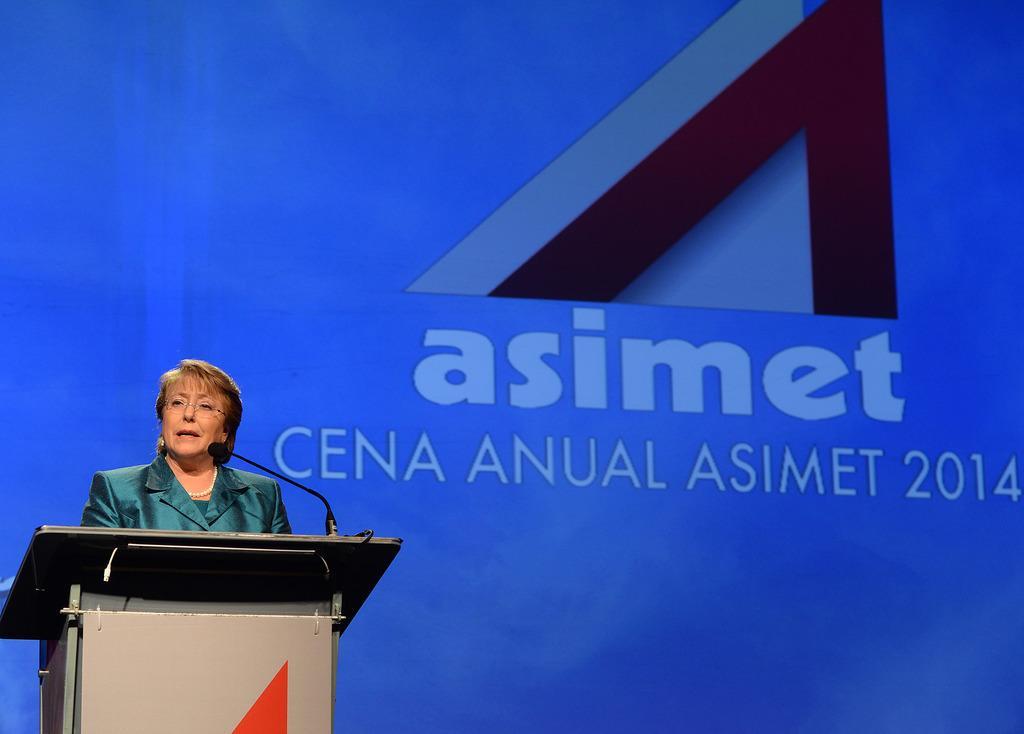In one or two sentences, can you explain what this image depicts? In this picture we can see a woman on the left side, we can see a microphone and a podium in front of her, in the background there is some text. 